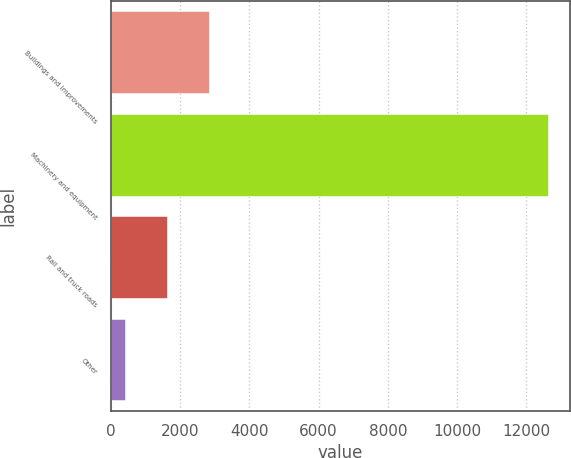Convert chart to OTSL. <chart><loc_0><loc_0><loc_500><loc_500><bar_chart><fcel>Buildings and improvements<fcel>Machinery and equipment<fcel>Rail and truck roads<fcel>Other<nl><fcel>2840.8<fcel>12640<fcel>1615.9<fcel>391<nl></chart> 